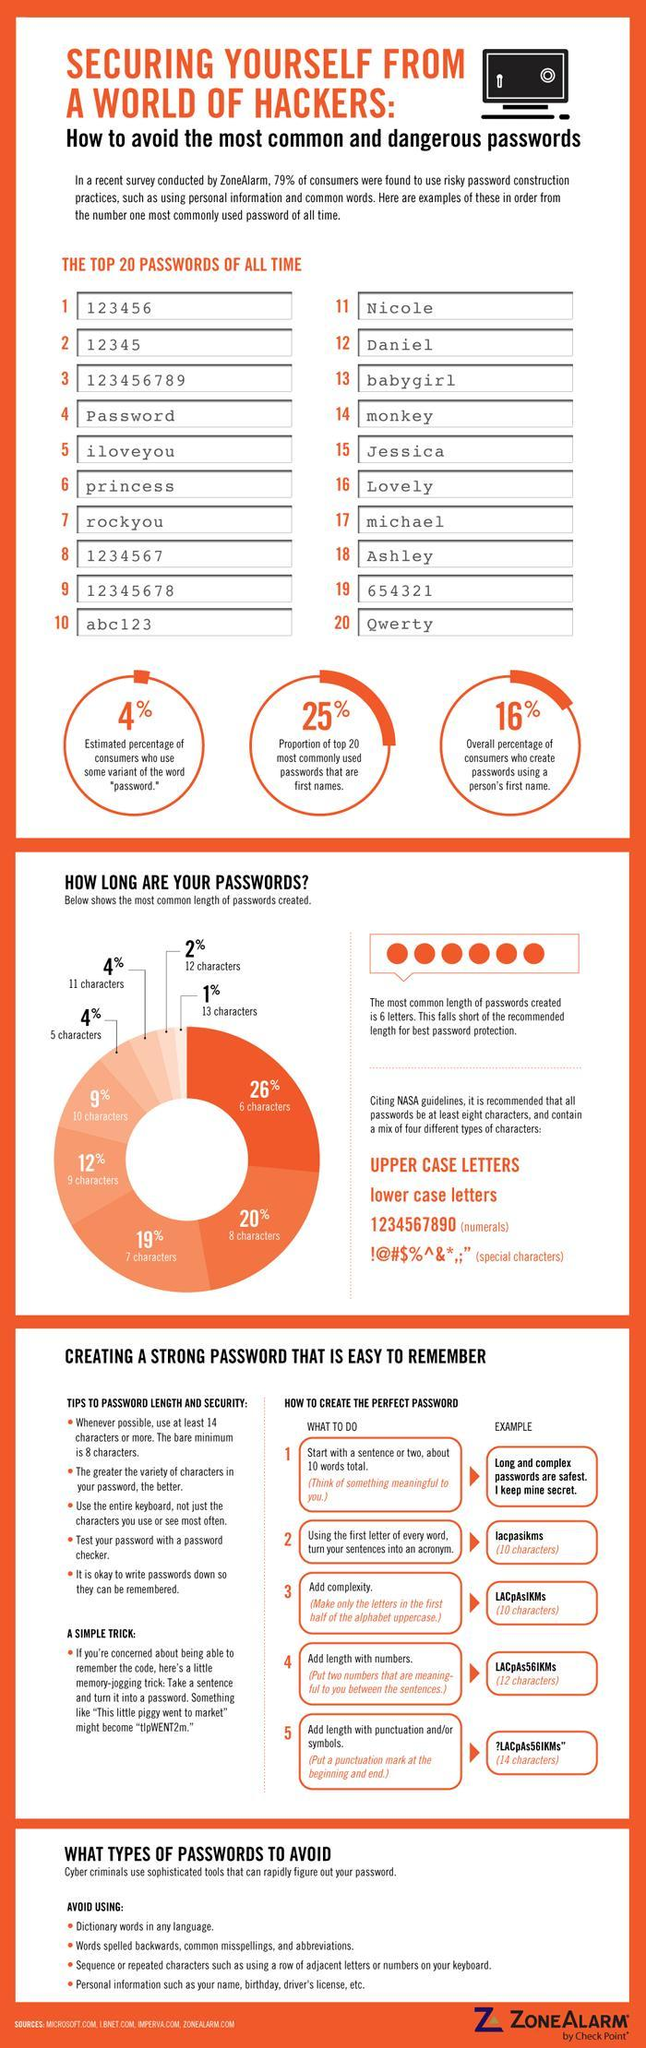What percentage of the password created are of six characters?
Answer the question with a short phrase. 26% What is the estimated percentage of consumers who use some variant of the word "password"? 4% What is the overall percentage of consumers who create passwords using a person's first name? 16% What percentage of the password created are of 13 characters? 1% What percentage of the password created are of ten characters? 9% 